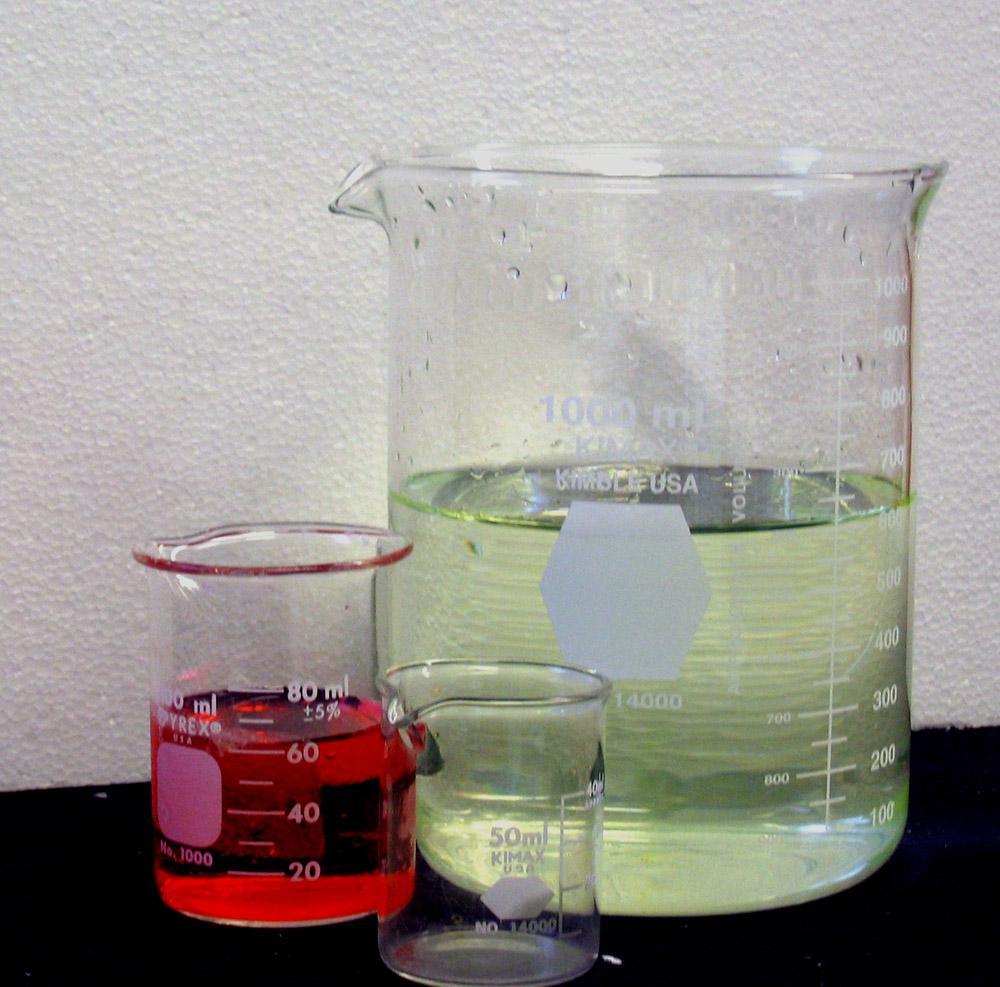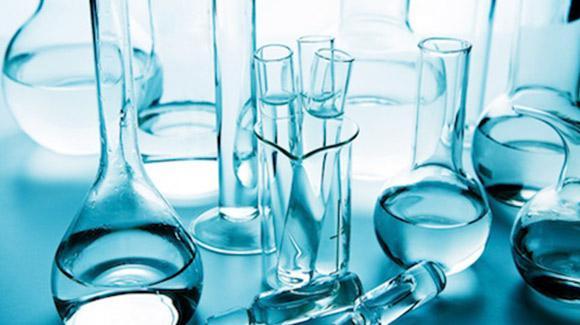The first image is the image on the left, the second image is the image on the right. Assess this claim about the two images: "There are at most 3 laboratory flasks in the left image.". Correct or not? Answer yes or no. Yes. The first image is the image on the left, the second image is the image on the right. Evaluate the accuracy of this statement regarding the images: "An image shows beakers containing multiple liquid colors, including red, yellow, and blue.". Is it true? Answer yes or no. No. 